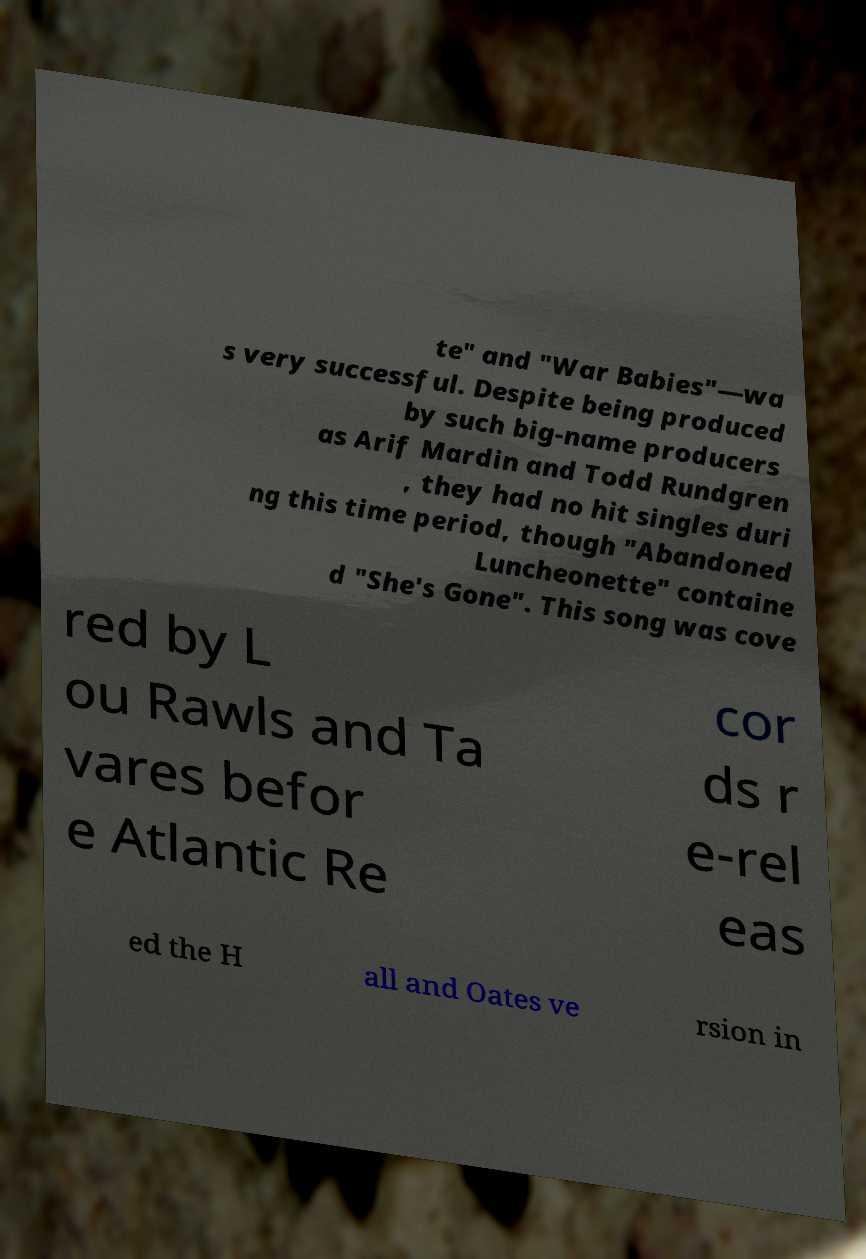I need the written content from this picture converted into text. Can you do that? te" and "War Babies"—wa s very successful. Despite being produced by such big-name producers as Arif Mardin and Todd Rundgren , they had no hit singles duri ng this time period, though "Abandoned Luncheonette" containe d "She's Gone". This song was cove red by L ou Rawls and Ta vares befor e Atlantic Re cor ds r e-rel eas ed the H all and Oates ve rsion in 